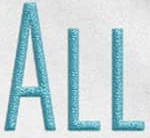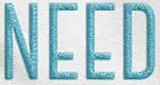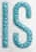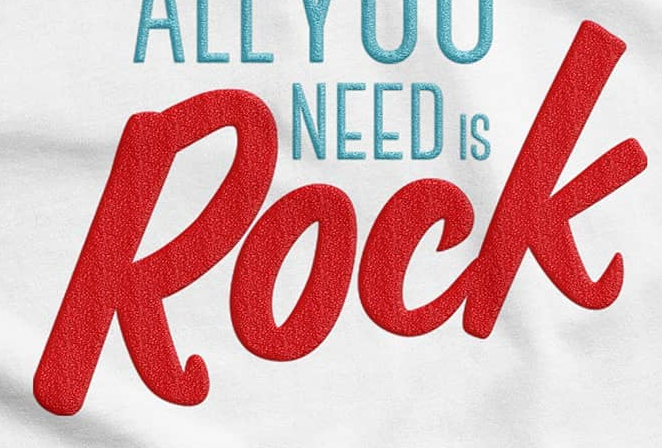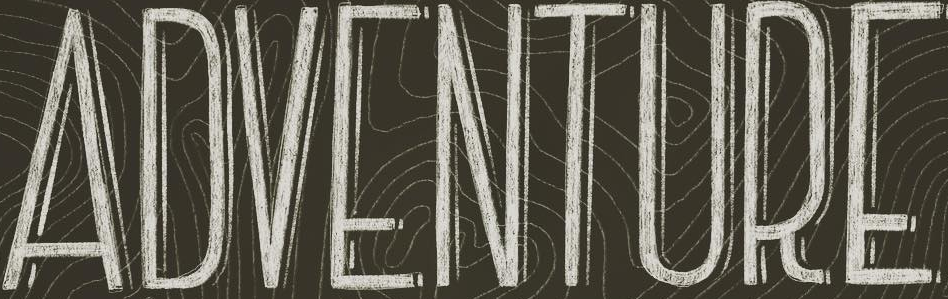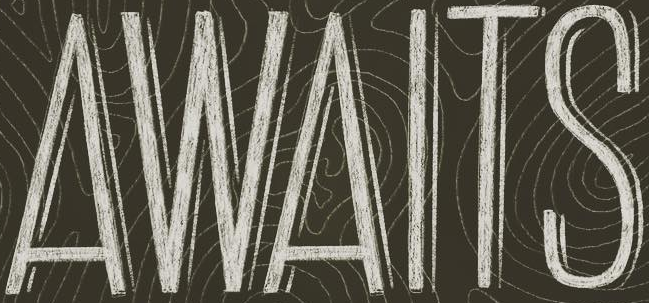What text is displayed in these images sequentially, separated by a semicolon? ALL; NEED; IS; Rock; ADVENTURE; AWAITS 